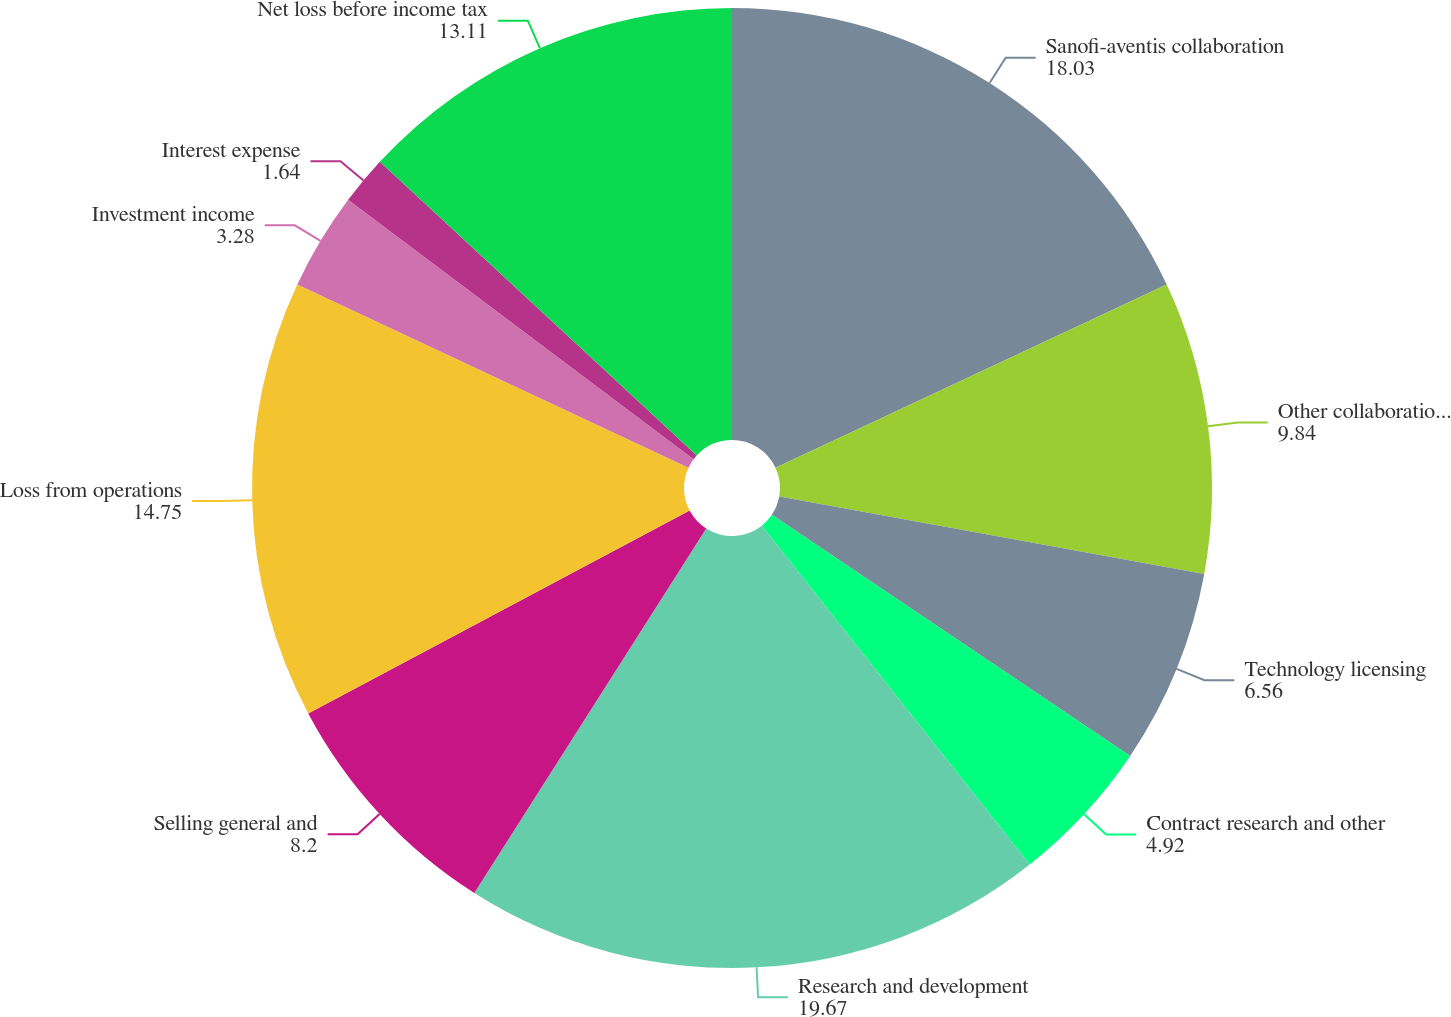Convert chart. <chart><loc_0><loc_0><loc_500><loc_500><pie_chart><fcel>Sanofi-aventis collaboration<fcel>Other collaboration revenue<fcel>Technology licensing<fcel>Contract research and other<fcel>Research and development<fcel>Selling general and<fcel>Loss from operations<fcel>Investment income<fcel>Interest expense<fcel>Net loss before income tax<nl><fcel>18.03%<fcel>9.84%<fcel>6.56%<fcel>4.92%<fcel>19.67%<fcel>8.2%<fcel>14.75%<fcel>3.28%<fcel>1.64%<fcel>13.11%<nl></chart> 